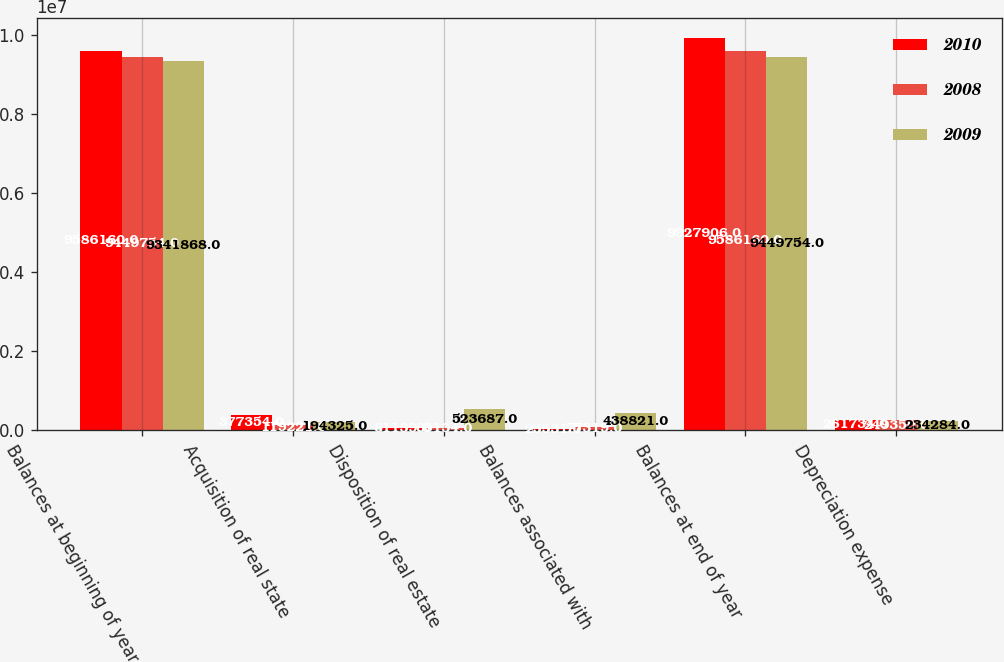Convert chart to OTSL. <chart><loc_0><loc_0><loc_500><loc_500><stacked_bar_chart><ecel><fcel>Balances at beginning of year<fcel>Acquisition of real state<fcel>Disposition of real estate<fcel>Balances associated with<fcel>Balances at end of year<fcel>Depreciation expense<nl><fcel>2010<fcel>9.58616e+06<fcel>377354<fcel>61139<fcel>25531<fcel>9.92791e+06<fcel>261734<nl><fcel>2008<fcel>9.44975e+06<fcel>119221<fcel>60134<fcel>77319<fcel>9.58616e+06<fcel>249350<nl><fcel>2009<fcel>9.34187e+06<fcel>194325<fcel>523687<fcel>438821<fcel>9.44975e+06<fcel>234284<nl></chart> 